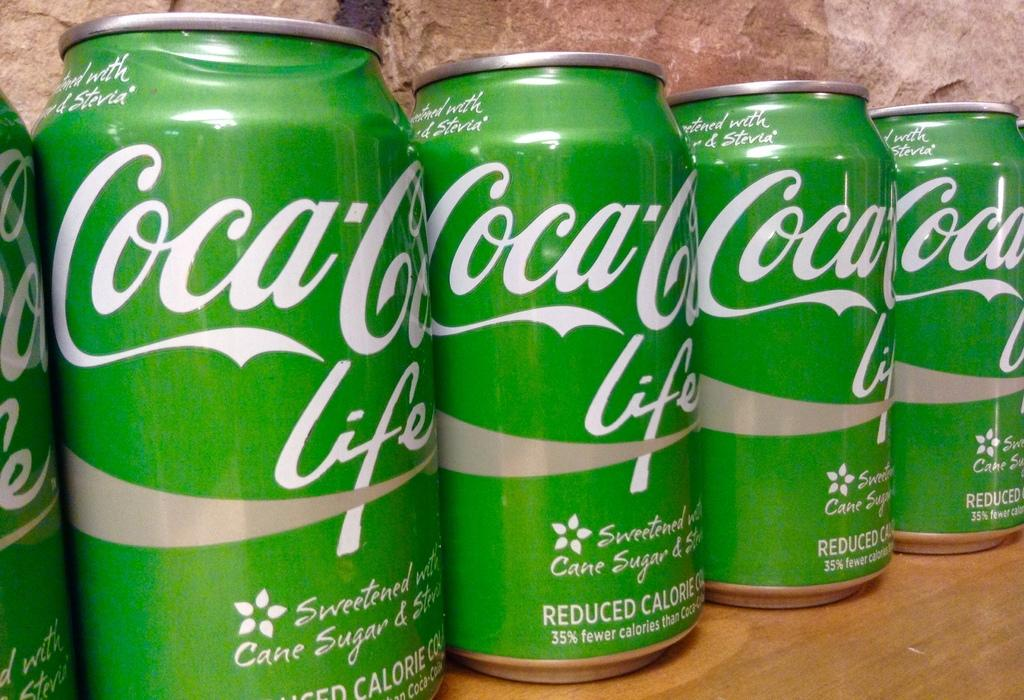What color are the tins in the image? The tins in the image are green. How are the green tins arranged in the image? The green tins are arranged on a wooden table. What can be seen in the background of the image? There is a wall in the background of the image. How many men are standing on the feet of the dog in the image? There are no men or dogs present in the image; it only features green tins arranged on a wooden table with a wall in the background. 